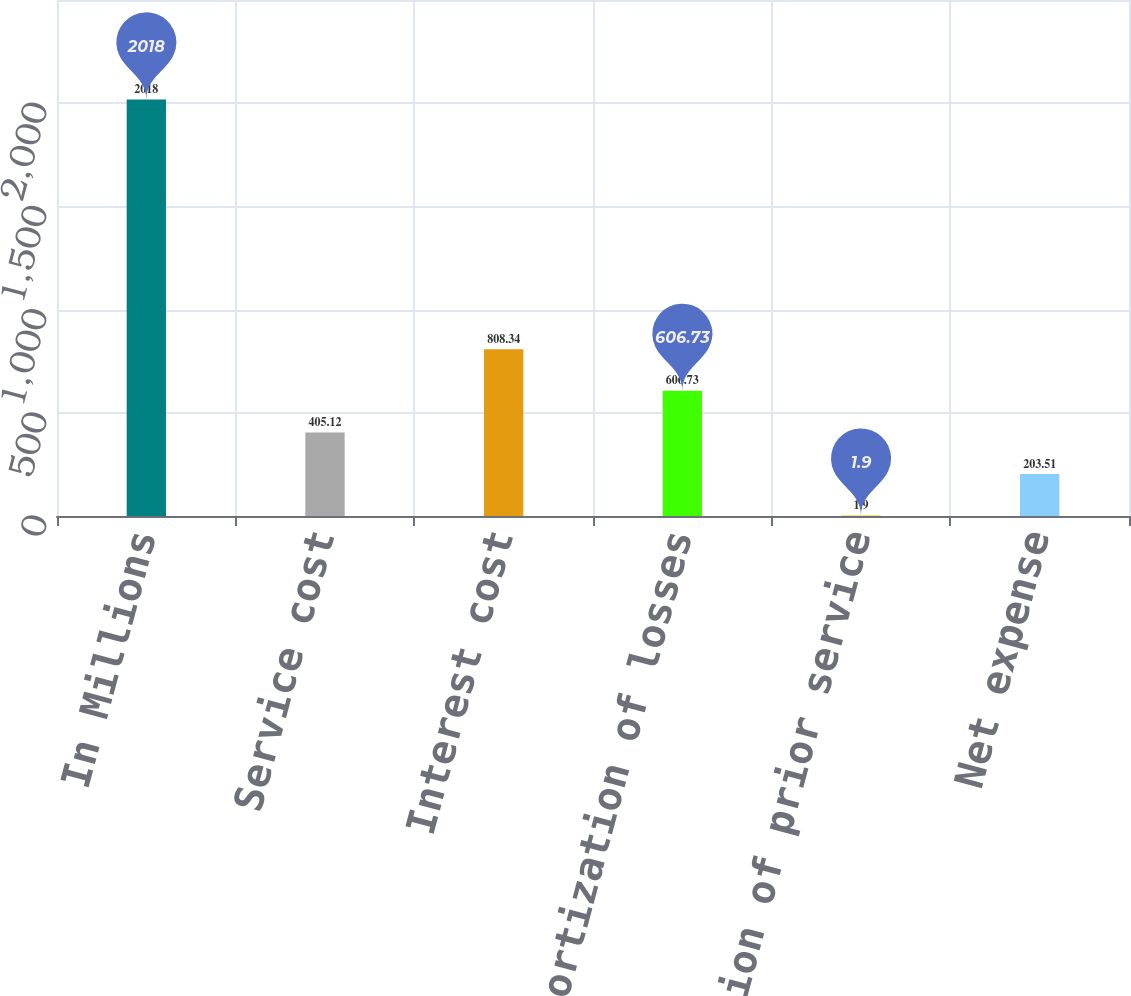Convert chart to OTSL. <chart><loc_0><loc_0><loc_500><loc_500><bar_chart><fcel>In Millions<fcel>Service cost<fcel>Interest cost<fcel>Amortization of losses<fcel>Amortization of prior service<fcel>Net expense<nl><fcel>2018<fcel>405.12<fcel>808.34<fcel>606.73<fcel>1.9<fcel>203.51<nl></chart> 